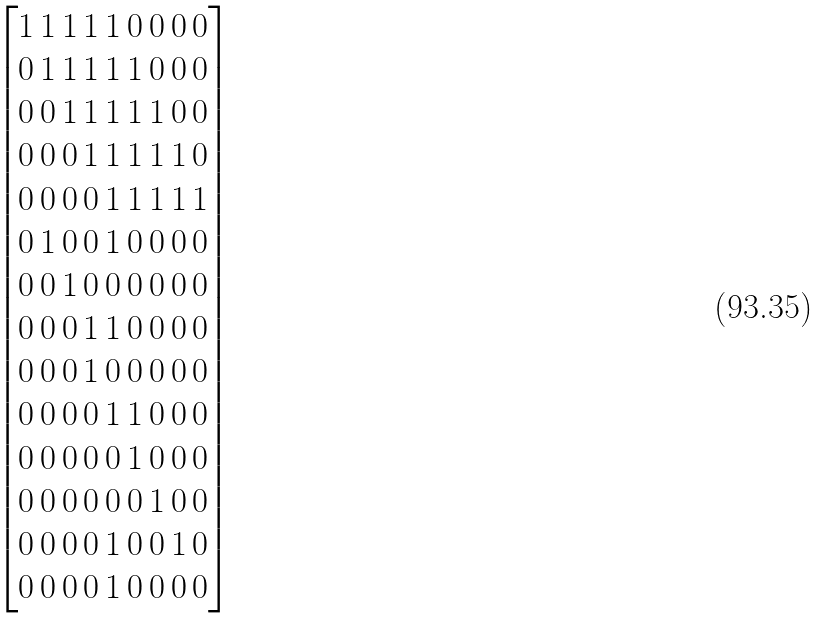<formula> <loc_0><loc_0><loc_500><loc_500>\begin{bmatrix} 1 \, 1 \, 1 \, 1 \, 1 \, 0 \, 0 \, 0 \, 0 \\ 0 \, 1 \, 1 \, 1 \, 1 \, 1 \, 0 \, 0 \, 0 \\ 0 \, 0 \, 1 \, 1 \, 1 \, 1 \, 1 \, 0 \, 0 \\ 0 \, 0 \, 0 \, 1 \, 1 \, 1 \, 1 \, 1 \, 0 \\ 0 \, 0 \, 0 \, 0 \, 1 \, 1 \, 1 \, 1 \, 1 \\ 0 \, 1 \, 0 \, 0 \, 1 \, 0 \, 0 \, 0 \, 0 \\ 0 \, 0 \, 1 \, 0 \, 0 \, 0 \, 0 \, 0 \, 0 \\ 0 \, 0 \, 0 \, 1 \, 1 \, 0 \, 0 \, 0 \, 0 \\ 0 \, 0 \, 0 \, 1 \, 0 \, 0 \, 0 \, 0 \, 0 \\ 0 \, 0 \, 0 \, 0 \, 1 \, 1 \, 0 \, 0 \, 0 \\ 0 \, 0 \, 0 \, 0 \, 0 \, 1 \, 0 \, 0 \, 0 \\ 0 \, 0 \, 0 \, 0 \, 0 \, 0 \, 1 \, 0 \, 0 \\ 0 \, 0 \, 0 \, 0 \, 1 \, 0 \, 0 \, 1 \, 0 \\ 0 \, 0 \, 0 \, 0 \, 1 \, 0 \, 0 \, 0 \, 0 \end{bmatrix}</formula> 